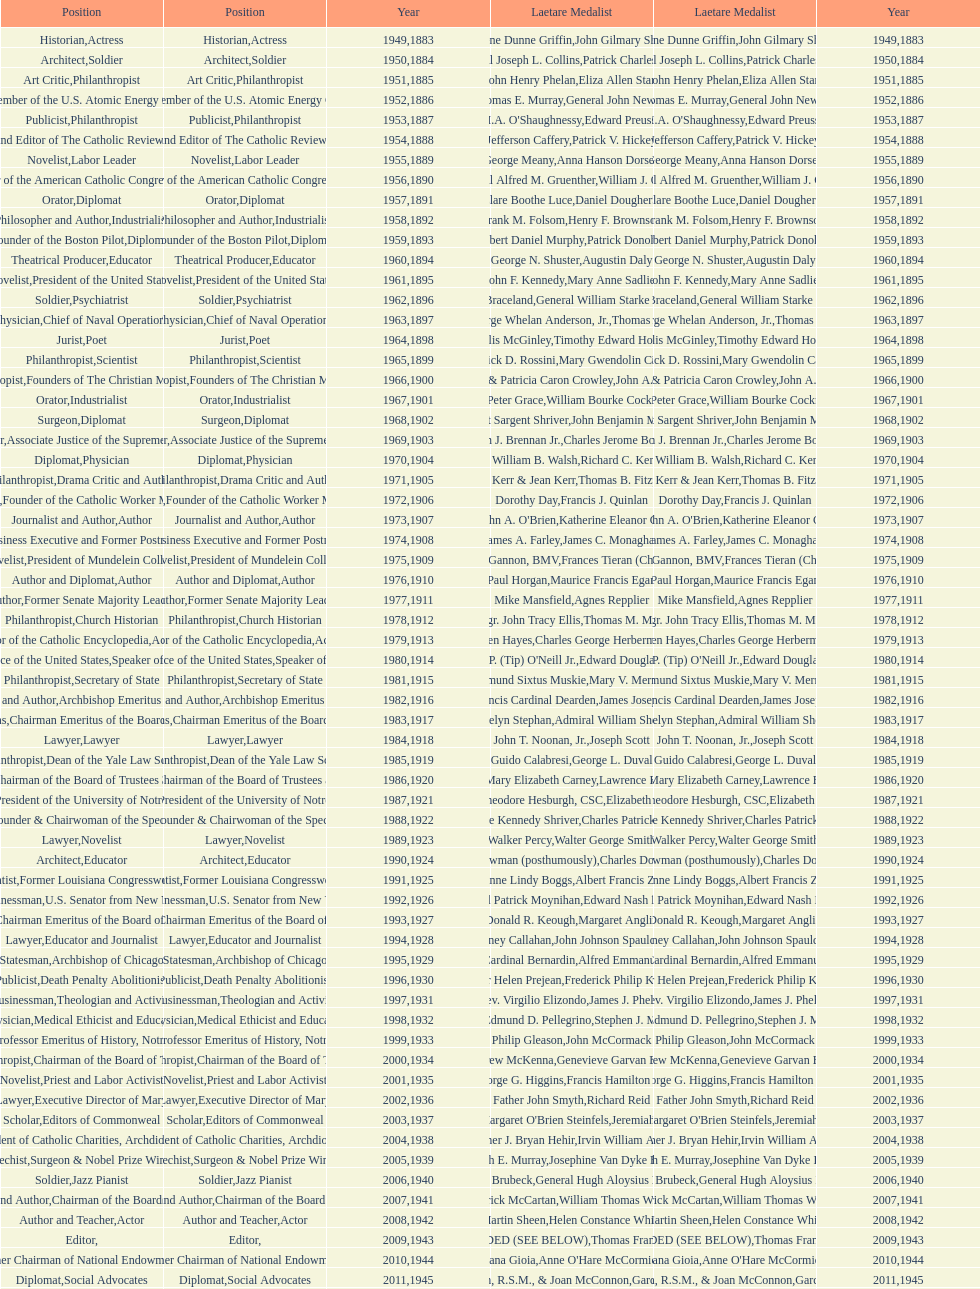How many lawyers have won the award between 1883 and 2014? 5. 